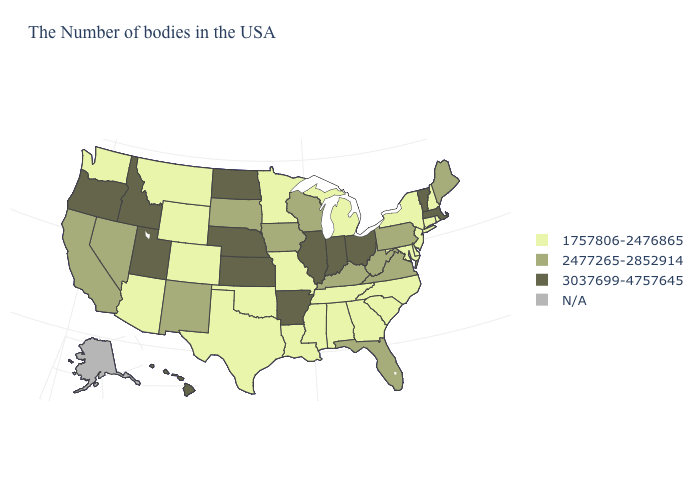What is the lowest value in states that border Washington?
Write a very short answer. 3037699-4757645. Which states have the highest value in the USA?
Quick response, please. Massachusetts, Vermont, Ohio, Indiana, Illinois, Arkansas, Kansas, Nebraska, North Dakota, Utah, Idaho, Oregon, Hawaii. What is the value of Maryland?
Quick response, please. 1757806-2476865. Name the states that have a value in the range 3037699-4757645?
Be succinct. Massachusetts, Vermont, Ohio, Indiana, Illinois, Arkansas, Kansas, Nebraska, North Dakota, Utah, Idaho, Oregon, Hawaii. Does Florida have the highest value in the South?
Concise answer only. No. Name the states that have a value in the range 2477265-2852914?
Write a very short answer. Maine, Pennsylvania, Virginia, West Virginia, Florida, Kentucky, Wisconsin, Iowa, South Dakota, New Mexico, Nevada, California. Does Louisiana have the highest value in the USA?
Write a very short answer. No. Which states have the highest value in the USA?
Be succinct. Massachusetts, Vermont, Ohio, Indiana, Illinois, Arkansas, Kansas, Nebraska, North Dakota, Utah, Idaho, Oregon, Hawaii. What is the value of Illinois?
Concise answer only. 3037699-4757645. What is the lowest value in the South?
Short answer required. 1757806-2476865. Does Indiana have the highest value in the MidWest?
Short answer required. Yes. Name the states that have a value in the range 2477265-2852914?
Write a very short answer. Maine, Pennsylvania, Virginia, West Virginia, Florida, Kentucky, Wisconsin, Iowa, South Dakota, New Mexico, Nevada, California. 